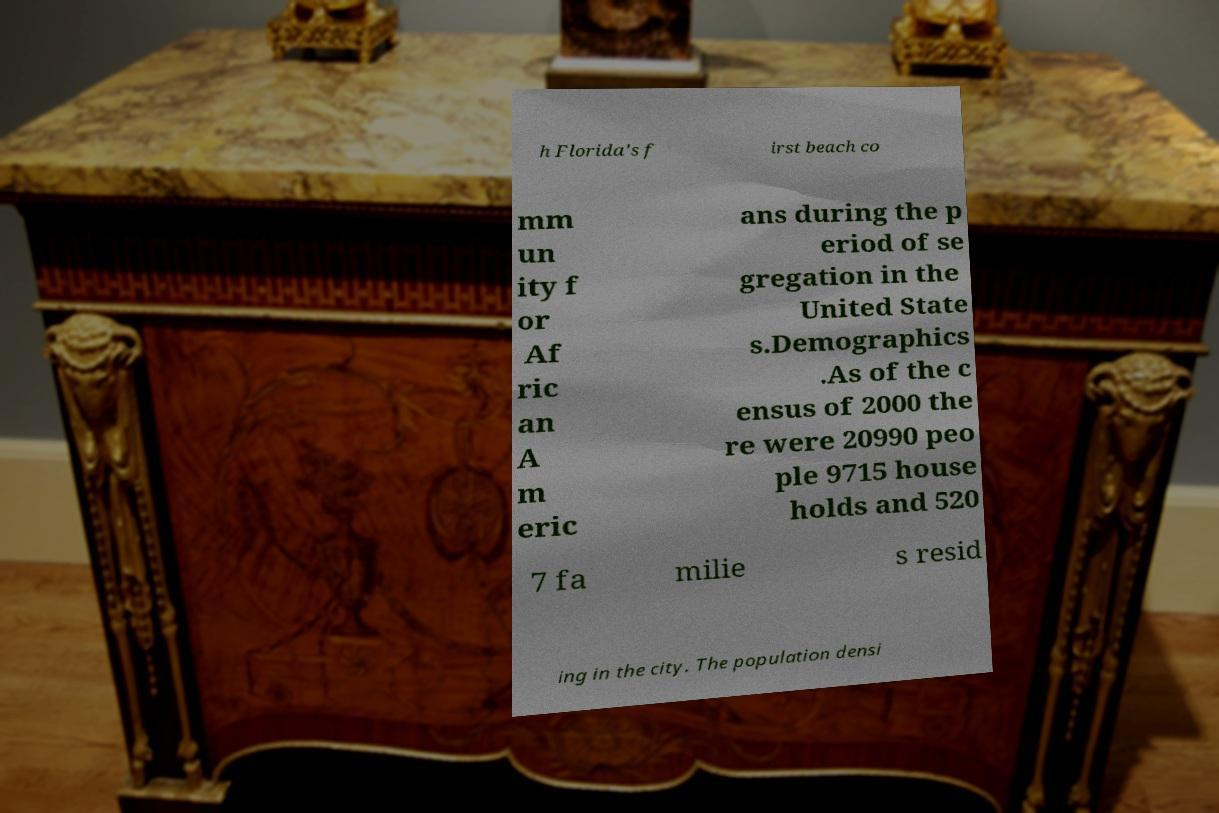Please identify and transcribe the text found in this image. h Florida's f irst beach co mm un ity f or Af ric an A m eric ans during the p eriod of se gregation in the United State s.Demographics .As of the c ensus of 2000 the re were 20990 peo ple 9715 house holds and 520 7 fa milie s resid ing in the city. The population densi 